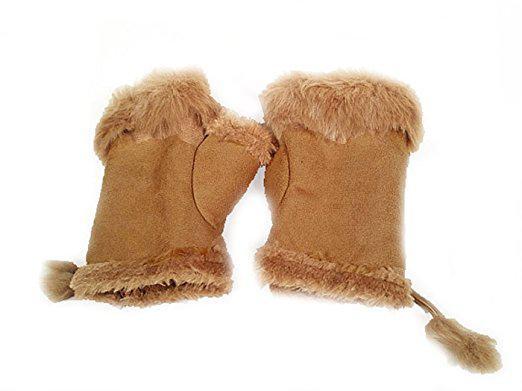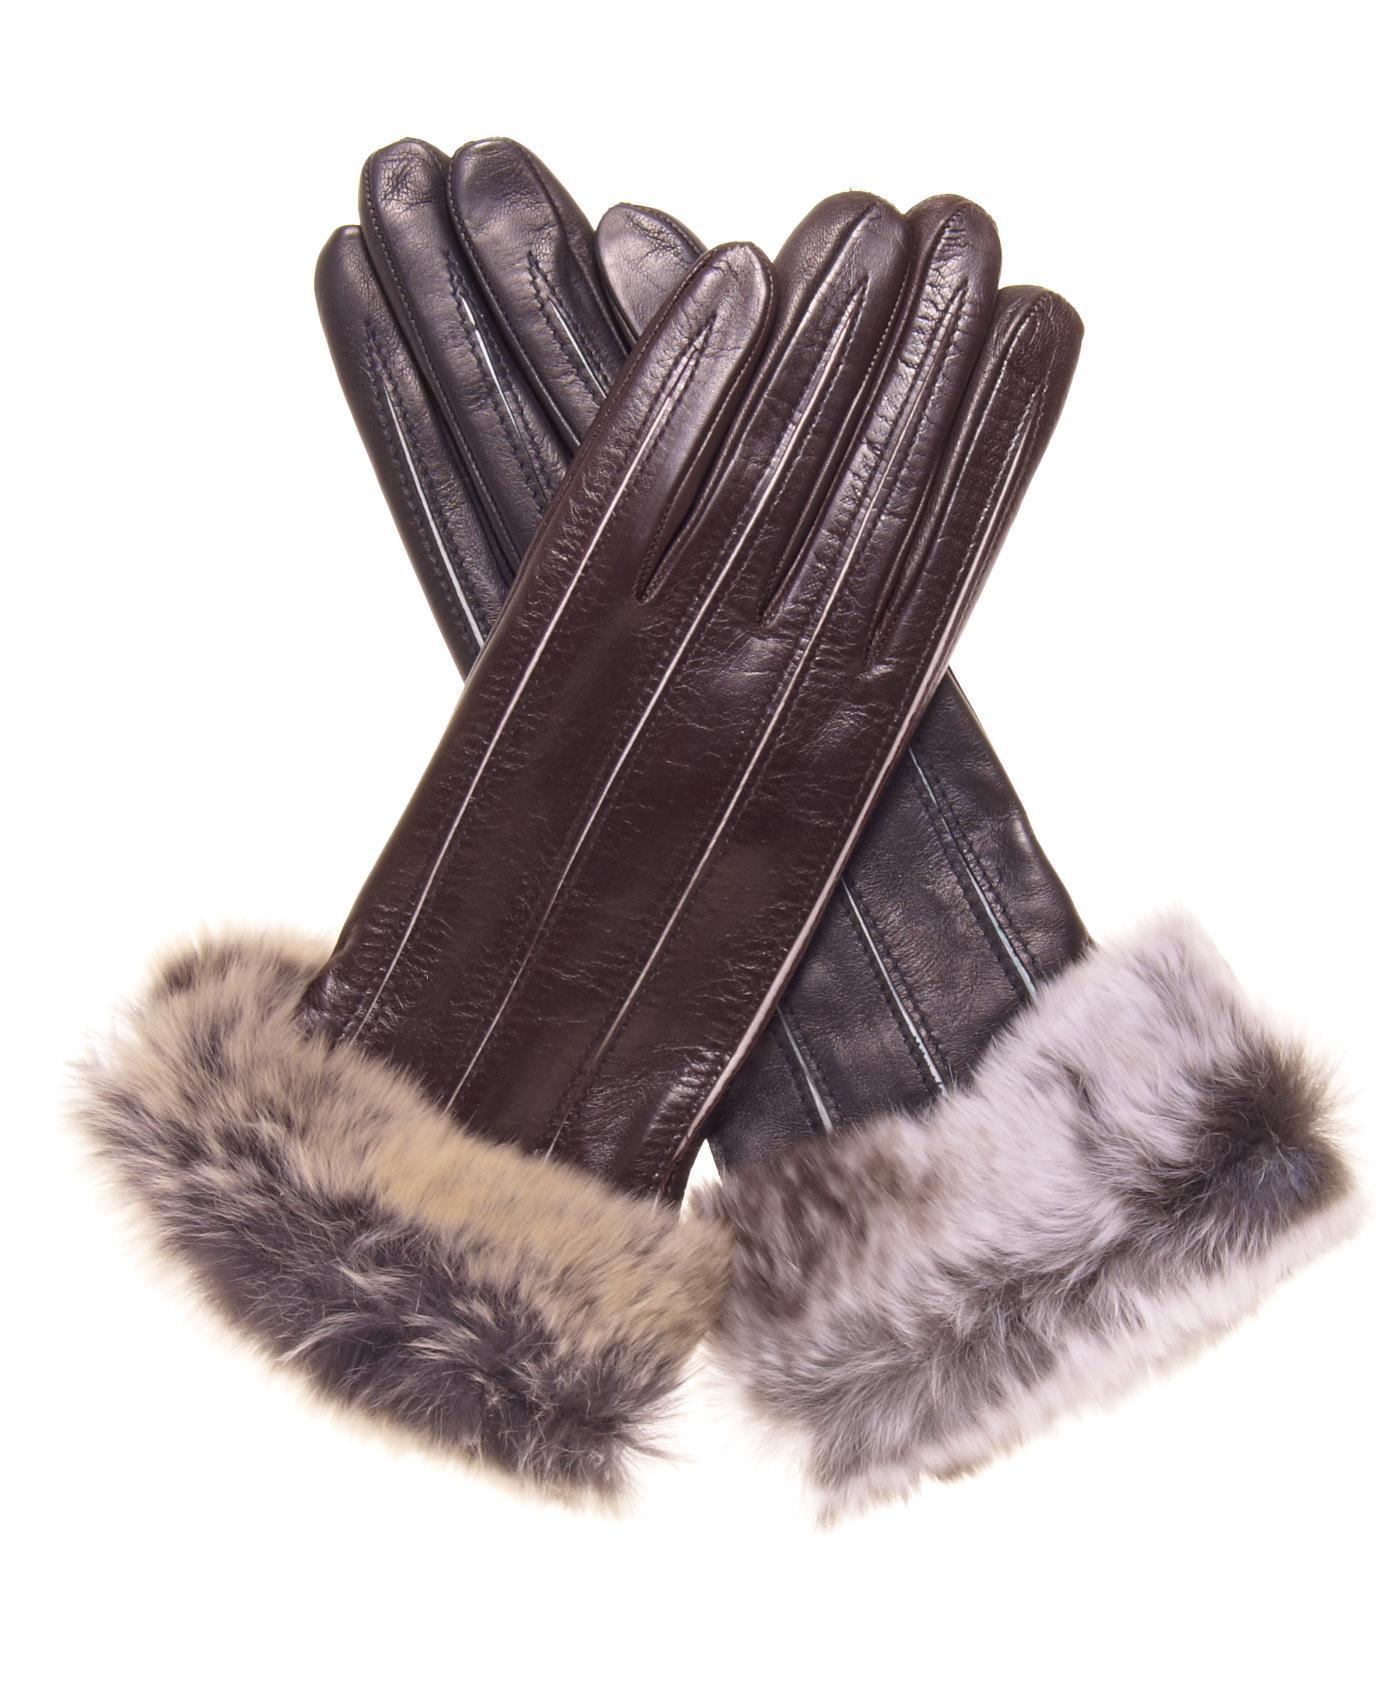The first image is the image on the left, the second image is the image on the right. Examine the images to the left and right. Is the description "One image shows human hands wearing gloves, and one shows a pair of unworn gloves." accurate? Answer yes or no. No. The first image is the image on the left, the second image is the image on the right. Analyze the images presented: Is the assertion "A dark brown pair of gloves are worn by a human hand." valid? Answer yes or no. No. 